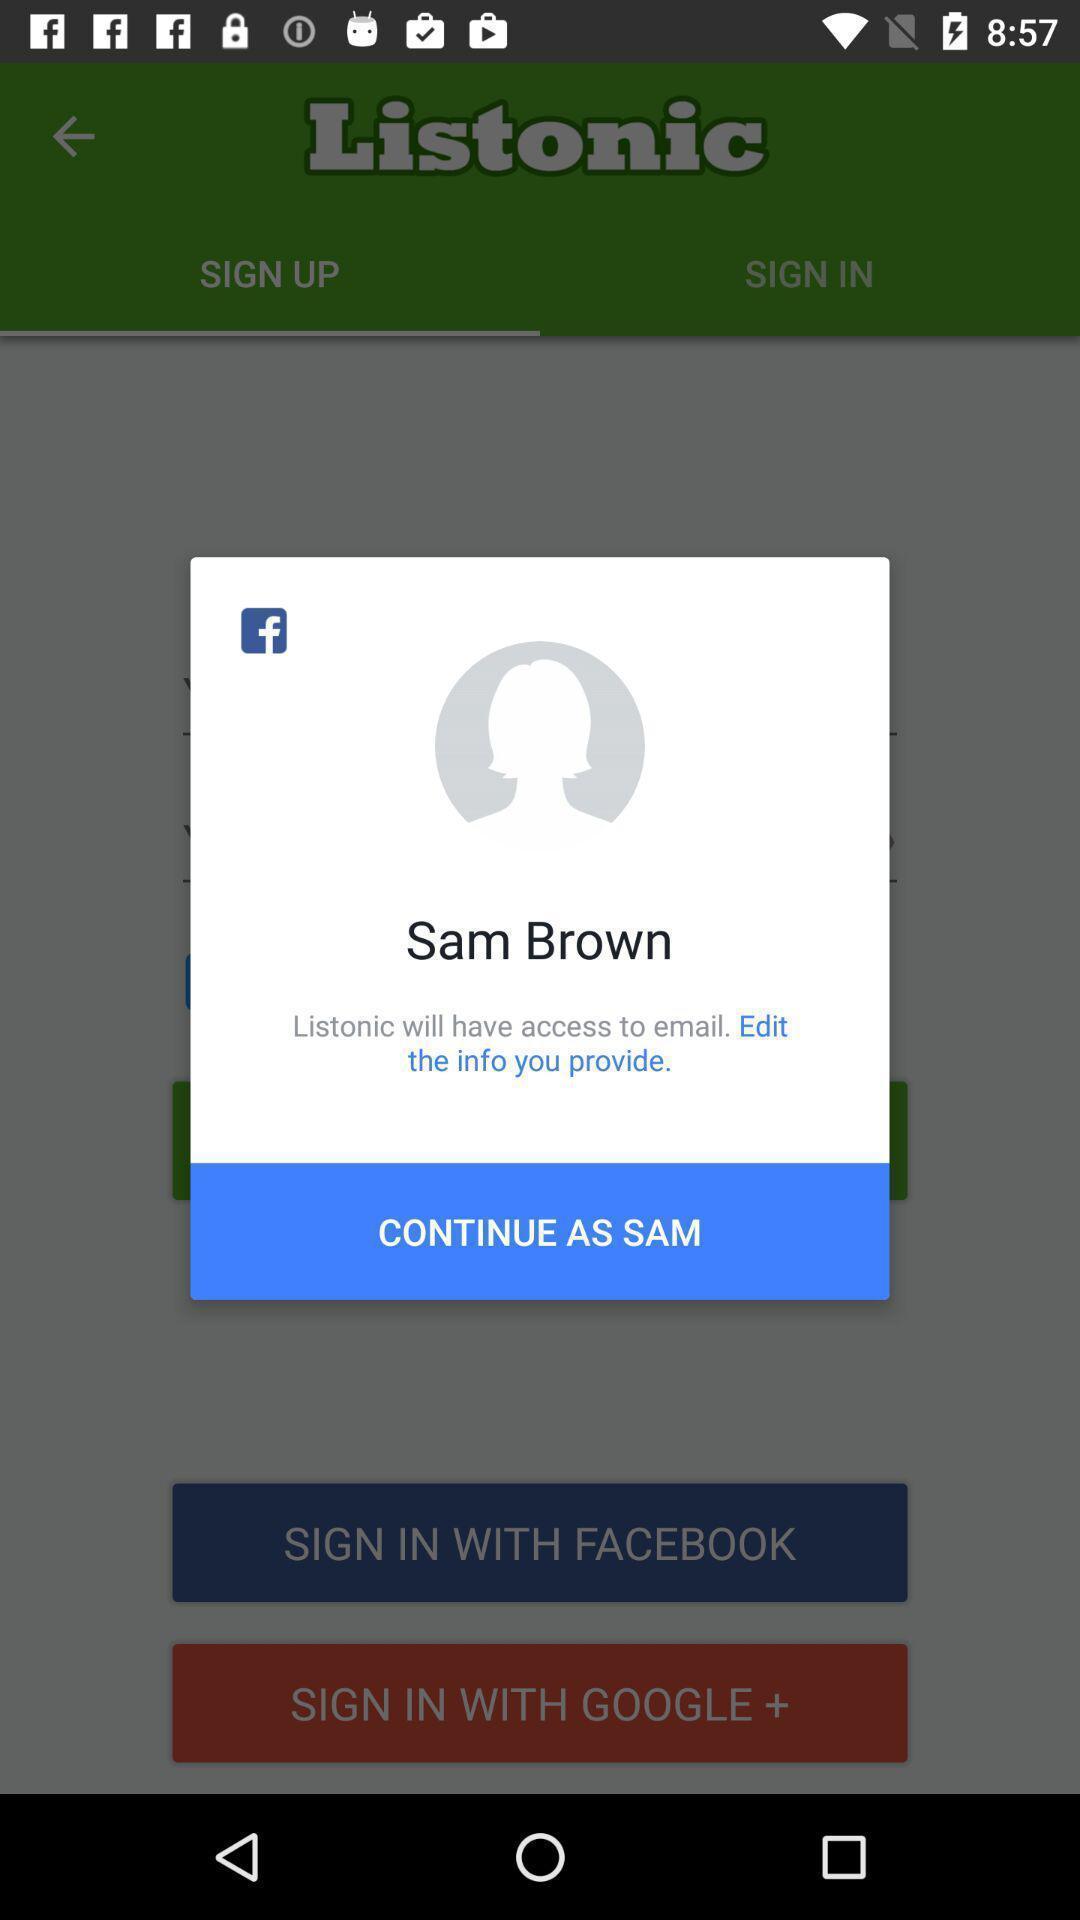Provide a description of this screenshot. Pop up showing social networking application. 